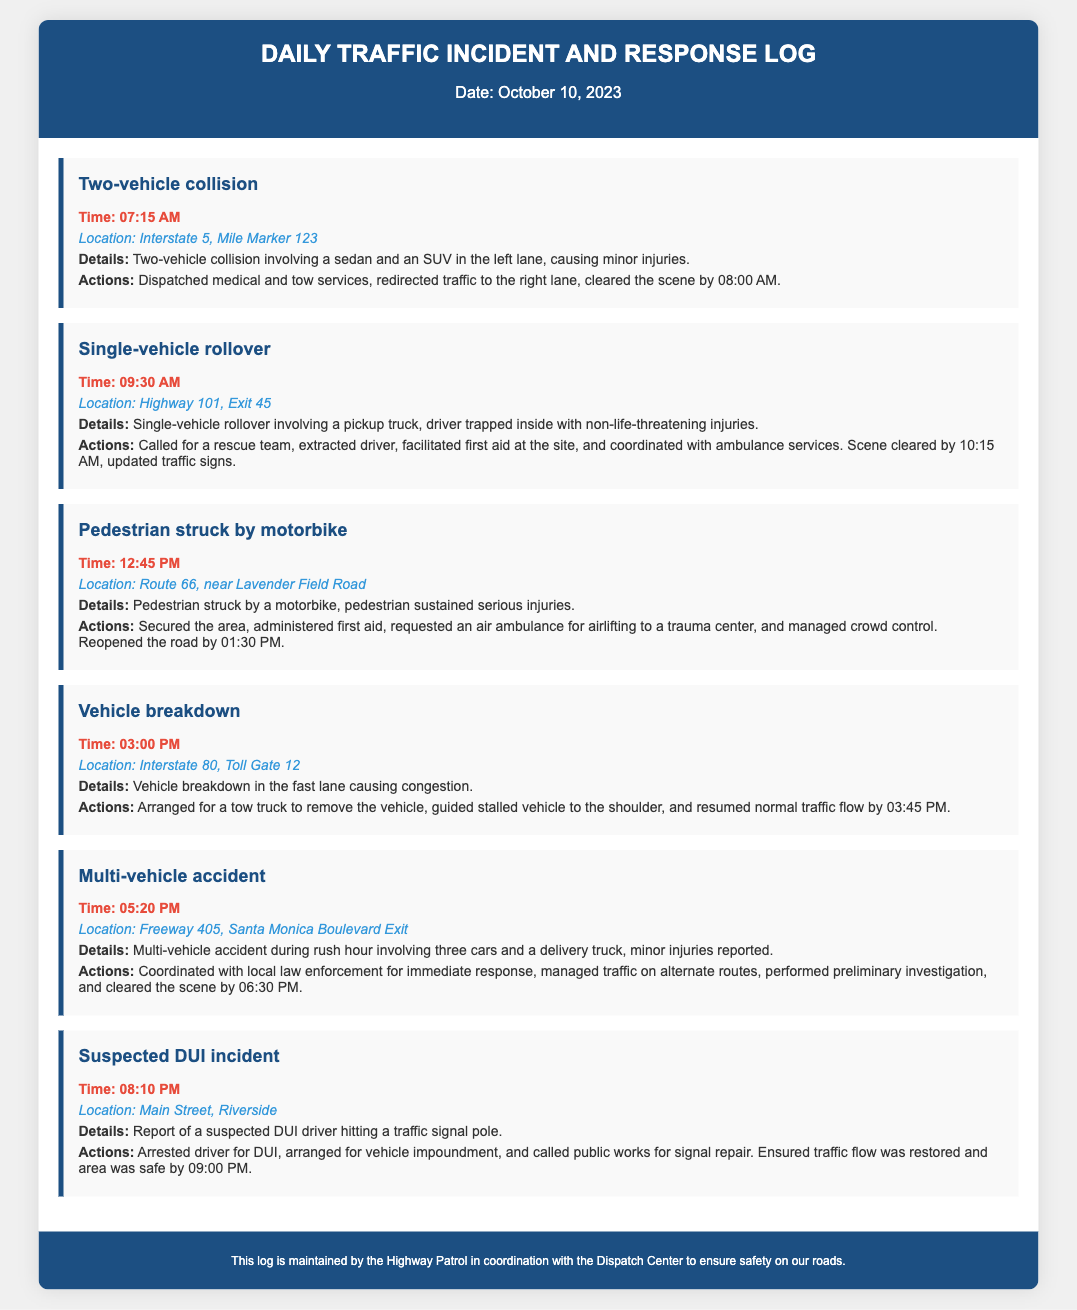What was the first incident reported? The first incident reported in the log is a two-vehicle collision.
Answer: Two-vehicle collision What time did the vehicle breakdown occur? The vehicle breakdown incident occurred at 03:00 PM.
Answer: 03:00 PM How many vehicles were involved in the multi-vehicle accident? The multi-vehicle accident involved three cars and a delivery truck.
Answer: Three cars and a delivery truck What specific action was taken for the pedestrian struck by a motorbike? An air ambulance was requested for airlifting to a trauma center.
Answer: Requested an air ambulance What was the outcome of the suspected DUI incident? The driver was arrested for DUI.
Answer: Arrested driver for DUI Which location experienced a single-vehicle rollover? The single-vehicle rollover occurred on Highway 101, Exit 45.
Answer: Highway 101, Exit 45 What time was the road reopened after the pedestrian incident? The road was reopened by 01:30 PM.
Answer: 01:30 PM What type of vehicle was involved in the first incident? A sedan and an SUV were involved in the first incident.
Answer: Sedan and SUV 